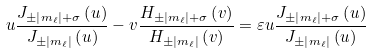<formula> <loc_0><loc_0><loc_500><loc_500>u \frac { J _ { \pm \left | m _ { \ell } \right | + \sigma } \left ( u \right ) } { J _ { \pm \left | m _ { \ell } \right | } \left ( u \right ) } - v \frac { H _ { \pm \left | m _ { \ell } \right | + \sigma } \left ( v \right ) } { H _ { \pm \left | m _ { \ell } \right | } \left ( v \right ) } = \varepsilon u \frac { J _ { \pm \left | m _ { \ell } \right | + \sigma } \left ( u \right ) } { J _ { \pm \left | m _ { \ell } \right | } \left ( u \right ) }</formula> 